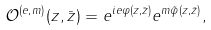<formula> <loc_0><loc_0><loc_500><loc_500>\mathcal { O } ^ { ( e , m ) } ( z , \bar { z } ) = e ^ { i e \varphi ( z , \bar { z } ) } e ^ { m \tilde { \varphi } ( z , \bar { z } ) } ,</formula> 